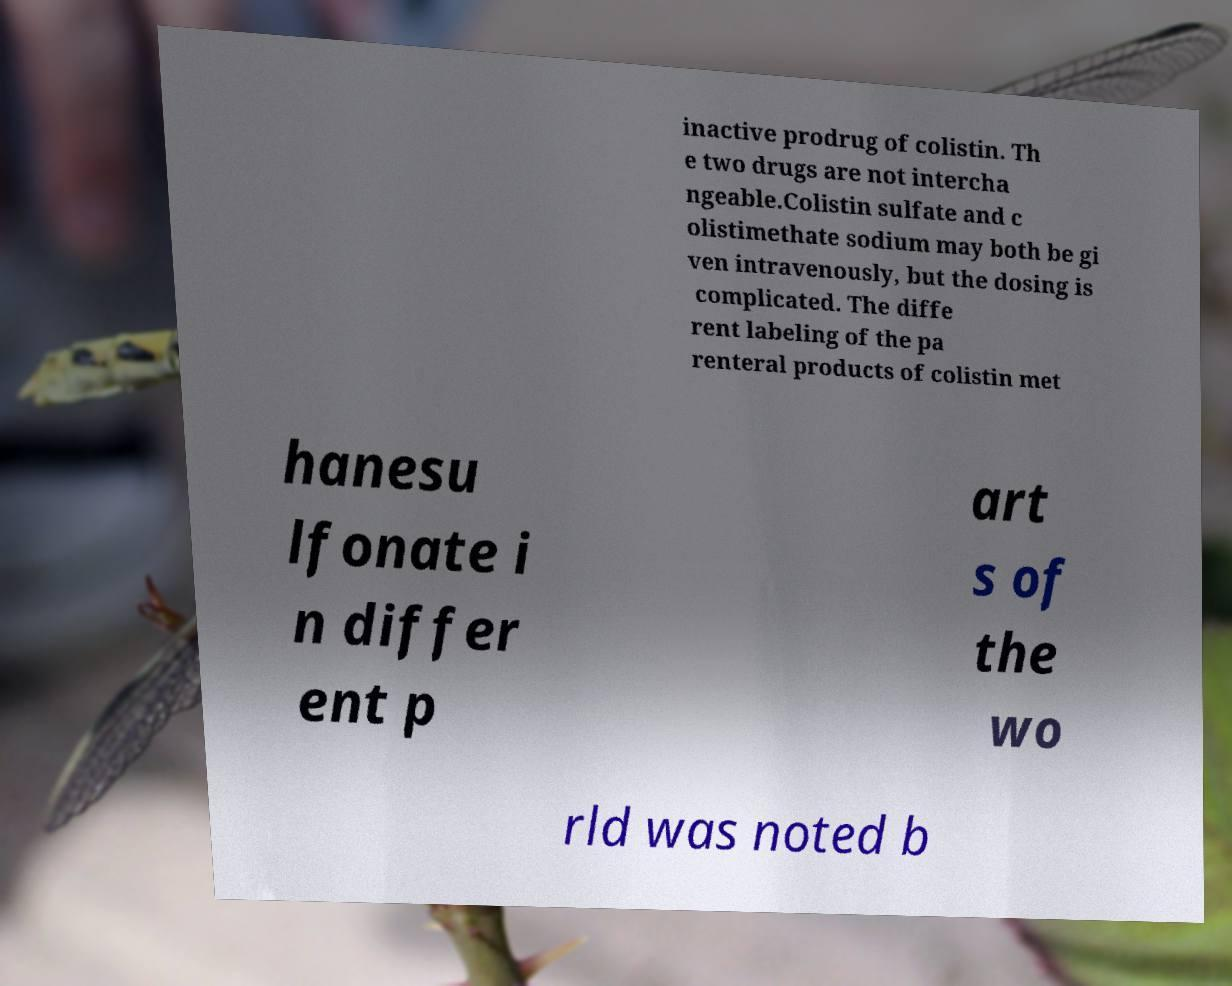Can you read and provide the text displayed in the image?This photo seems to have some interesting text. Can you extract and type it out for me? inactive prodrug of colistin. Th e two drugs are not intercha ngeable.Colistin sulfate and c olistimethate sodium may both be gi ven intravenously, but the dosing is complicated. The diffe rent labeling of the pa renteral products of colistin met hanesu lfonate i n differ ent p art s of the wo rld was noted b 